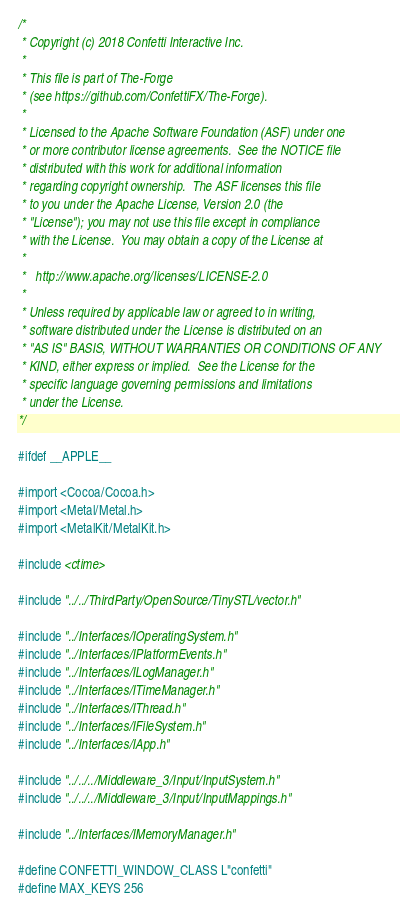Convert code to text. <code><loc_0><loc_0><loc_500><loc_500><_ObjectiveC_>/*
 * Copyright (c) 2018 Confetti Interactive Inc.
 *
 * This file is part of The-Forge
 * (see https://github.com/ConfettiFX/The-Forge).
 *
 * Licensed to the Apache Software Foundation (ASF) under one
 * or more contributor license agreements.  See the NOTICE file
 * distributed with this work for additional information
 * regarding copyright ownership.  The ASF licenses this file
 * to you under the Apache License, Version 2.0 (the
 * "License"); you may not use this file except in compliance
 * with the License.  You may obtain a copy of the License at
 *
 *   http://www.apache.org/licenses/LICENSE-2.0
 *
 * Unless required by applicable law or agreed to in writing,
 * software distributed under the License is distributed on an
 * "AS IS" BASIS, WITHOUT WARRANTIES OR CONDITIONS OF ANY
 * KIND, either express or implied.  See the License for the
 * specific language governing permissions and limitations
 * under the License.
*/

#ifdef __APPLE__

#import <Cocoa/Cocoa.h>
#import <Metal/Metal.h>
#import <MetalKit/MetalKit.h>

#include <ctime>

#include "../../ThirdParty/OpenSource/TinySTL/vector.h"

#include "../Interfaces/IOperatingSystem.h"
#include "../Interfaces/IPlatformEvents.h"
#include "../Interfaces/ILogManager.h"
#include "../Interfaces/ITimeManager.h"
#include "../Interfaces/IThread.h"
#include "../Interfaces/IFileSystem.h"
#include "../Interfaces/IApp.h"

#include "../../../Middleware_3/Input/InputSystem.h"
#include "../../../Middleware_3/Input/InputMappings.h"

#include "../Interfaces/IMemoryManager.h"

#define CONFETTI_WINDOW_CLASS L"confetti"
#define MAX_KEYS 256</code> 